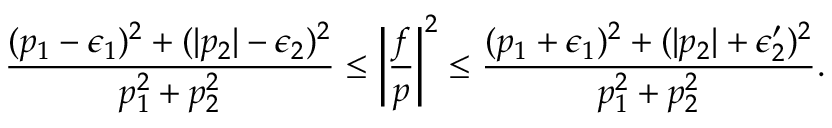<formula> <loc_0><loc_0><loc_500><loc_500>\frac { ( p _ { 1 } - \epsilon _ { 1 } ) ^ { 2 } + ( | p _ { 2 } | - \epsilon _ { 2 } ) ^ { 2 } } { p _ { 1 } ^ { 2 } + p _ { 2 } ^ { 2 } } \leq \left | \frac { f } { p } \right | ^ { 2 } \leq \frac { ( p _ { 1 } + \epsilon _ { 1 } ) ^ { 2 } + ( | p _ { 2 } | + \epsilon _ { 2 } ^ { \prime } ) ^ { 2 } } { p _ { 1 } ^ { 2 } + p _ { 2 } ^ { 2 } } .</formula> 